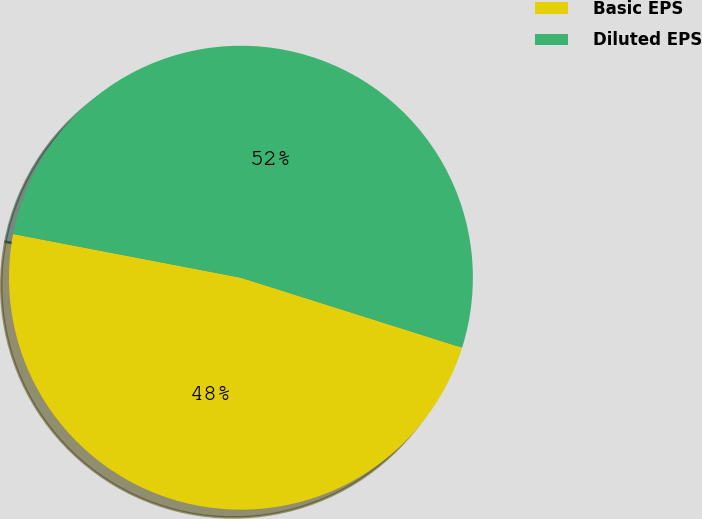Convert chart to OTSL. <chart><loc_0><loc_0><loc_500><loc_500><pie_chart><fcel>Basic EPS<fcel>Diluted EPS<nl><fcel>48.14%<fcel>51.86%<nl></chart> 